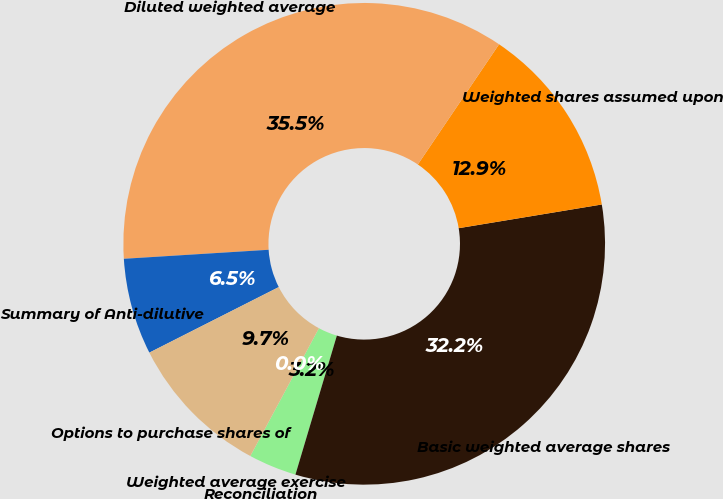Convert chart to OTSL. <chart><loc_0><loc_0><loc_500><loc_500><pie_chart><fcel>Reconciliation<fcel>Basic weighted average shares<fcel>Weighted shares assumed upon<fcel>Diluted weighted average<fcel>Summary of Anti-dilutive<fcel>Options to purchase shares of<fcel>Weighted average exercise<nl><fcel>3.23%<fcel>32.22%<fcel>12.93%<fcel>35.45%<fcel>6.47%<fcel>9.7%<fcel>0.0%<nl></chart> 